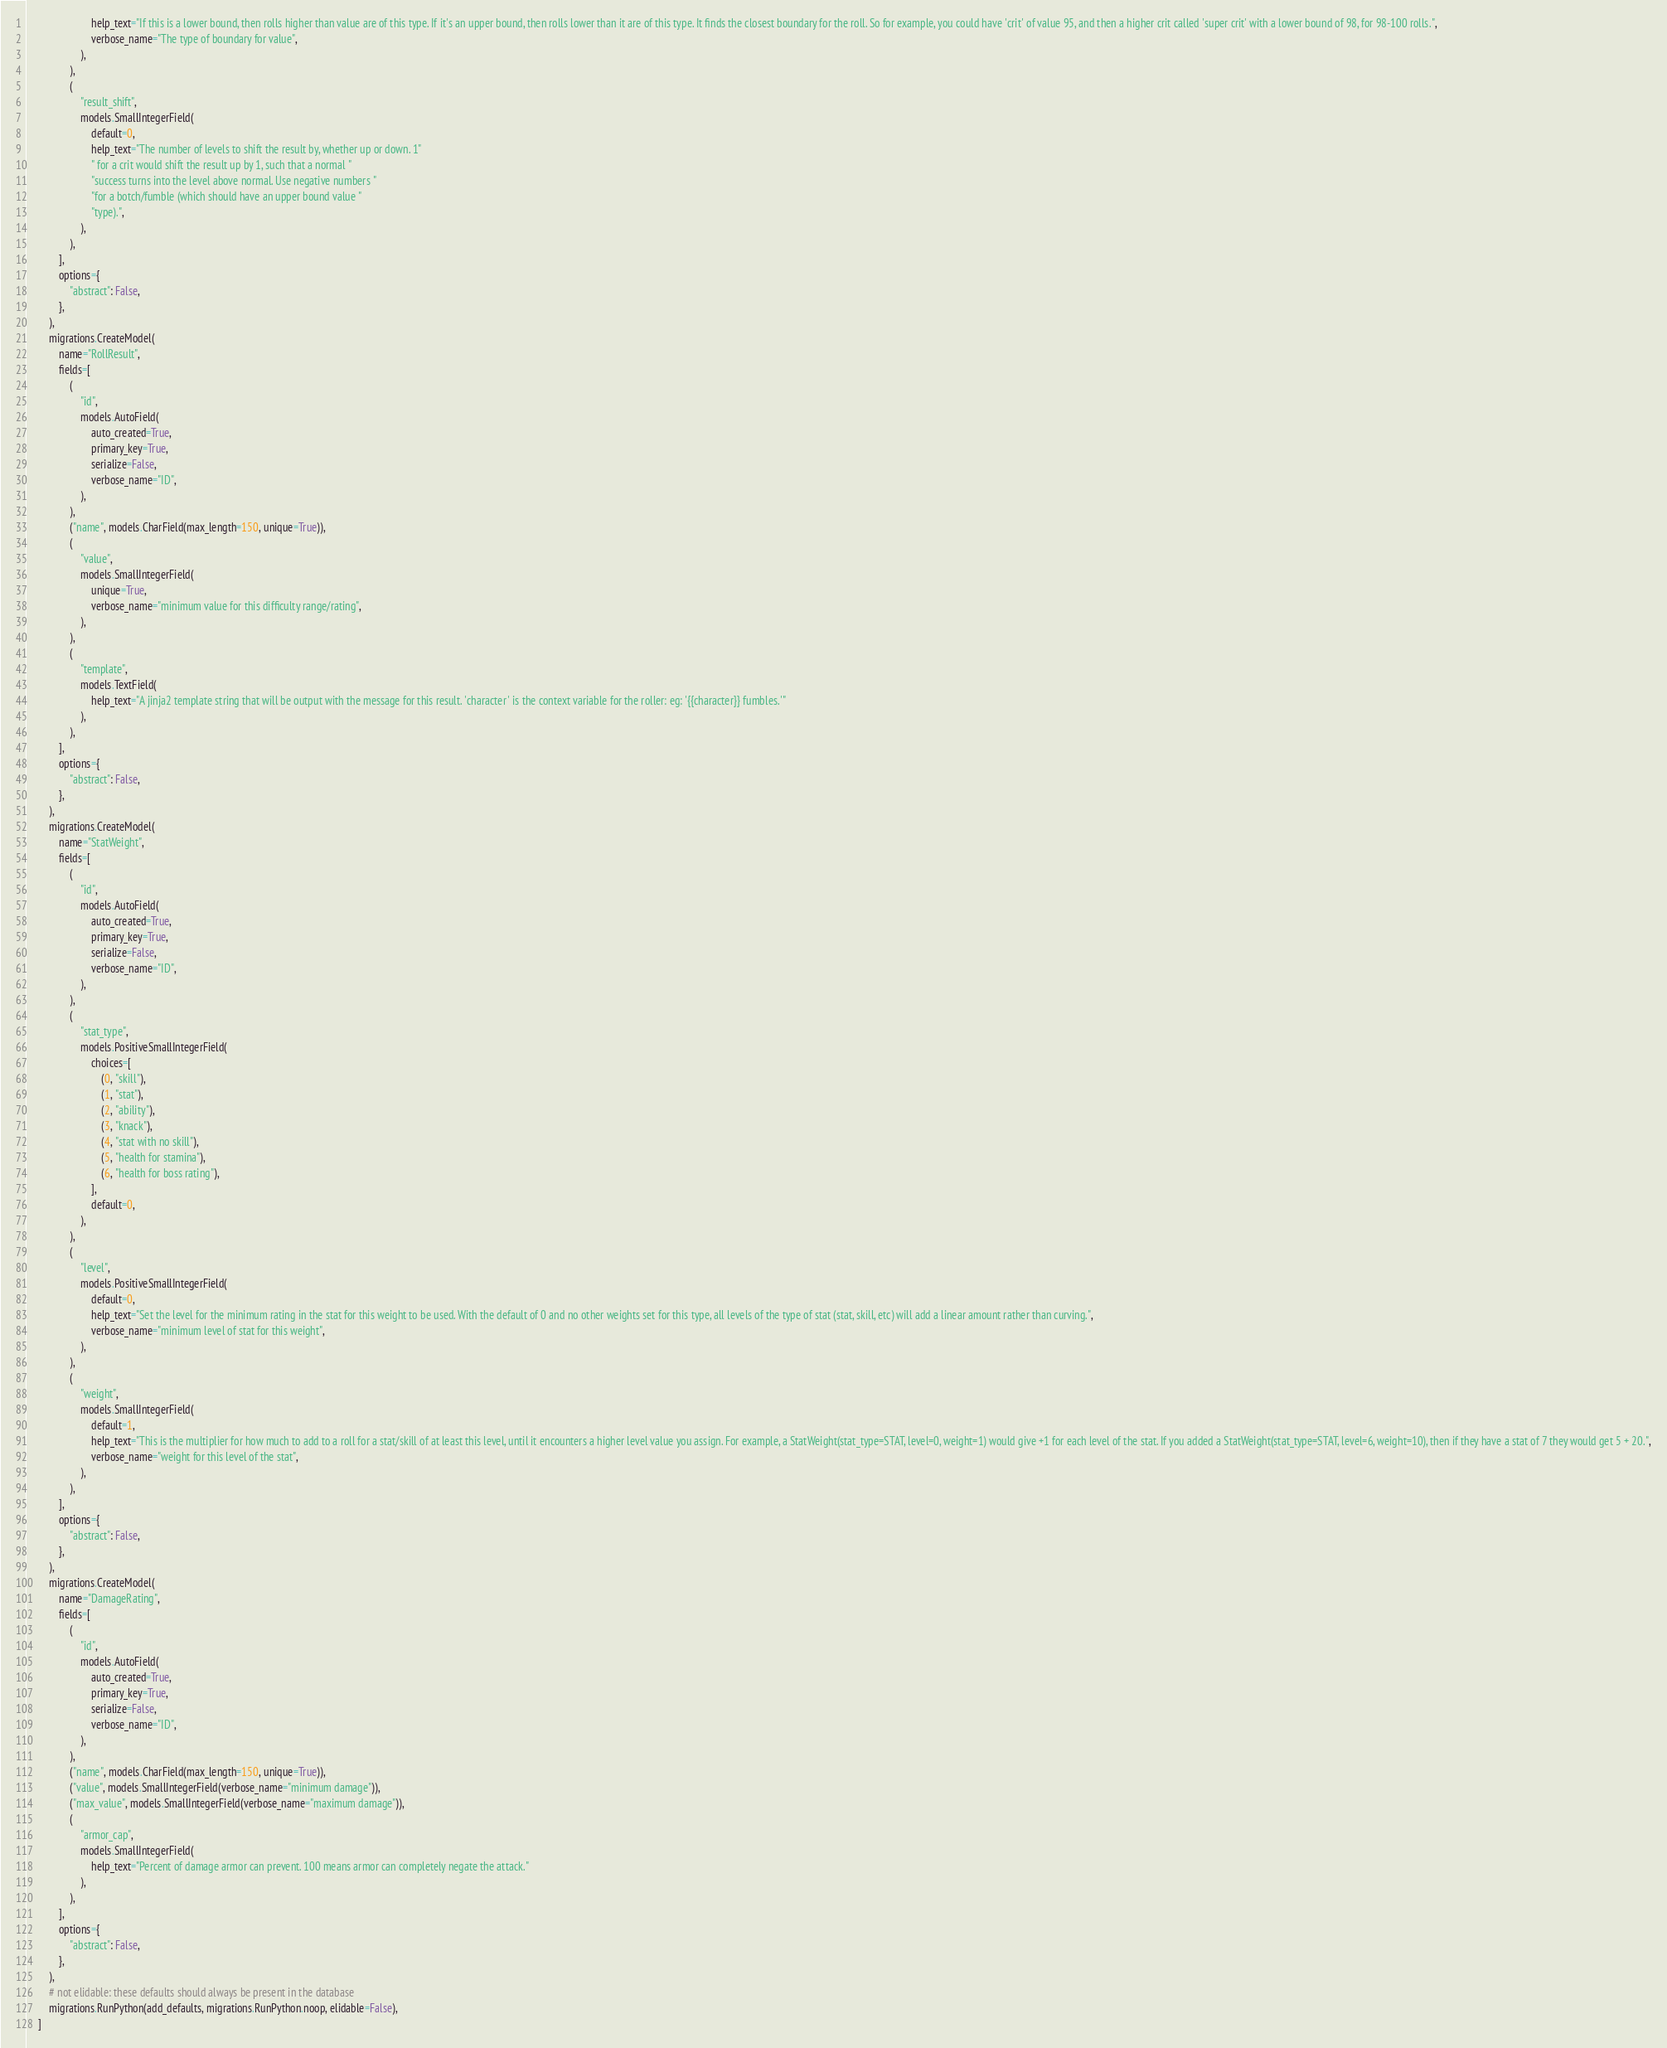Convert code to text. <code><loc_0><loc_0><loc_500><loc_500><_Python_>                        help_text="If this is a lower bound, then rolls higher than value are of this type. If it's an upper bound, then rolls lower than it are of this type. It finds the closest boundary for the roll. So for example, you could have 'crit' of value 95, and then a higher crit called 'super crit' with a lower bound of 98, for 98-100 rolls.",
                        verbose_name="The type of boundary for value",
                    ),
                ),
                (
                    "result_shift",
                    models.SmallIntegerField(
                        default=0,
                        help_text="The number of levels to shift the result by, whether up or down. 1"
                        " for a crit would shift the result up by 1, such that a normal "
                        "success turns into the level above normal. Use negative numbers "
                        "for a botch/fumble (which should have an upper bound value "
                        "type).",
                    ),
                ),
            ],
            options={
                "abstract": False,
            },
        ),
        migrations.CreateModel(
            name="RollResult",
            fields=[
                (
                    "id",
                    models.AutoField(
                        auto_created=True,
                        primary_key=True,
                        serialize=False,
                        verbose_name="ID",
                    ),
                ),
                ("name", models.CharField(max_length=150, unique=True)),
                (
                    "value",
                    models.SmallIntegerField(
                        unique=True,
                        verbose_name="minimum value for this difficulty range/rating",
                    ),
                ),
                (
                    "template",
                    models.TextField(
                        help_text="A jinja2 template string that will be output with the message for this result. 'character' is the context variable for the roller: eg: '{{character}} fumbles.'"
                    ),
                ),
            ],
            options={
                "abstract": False,
            },
        ),
        migrations.CreateModel(
            name="StatWeight",
            fields=[
                (
                    "id",
                    models.AutoField(
                        auto_created=True,
                        primary_key=True,
                        serialize=False,
                        verbose_name="ID",
                    ),
                ),
                (
                    "stat_type",
                    models.PositiveSmallIntegerField(
                        choices=[
                            (0, "skill"),
                            (1, "stat"),
                            (2, "ability"),
                            (3, "knack"),
                            (4, "stat with no skill"),
                            (5, "health for stamina"),
                            (6, "health for boss rating"),
                        ],
                        default=0,
                    ),
                ),
                (
                    "level",
                    models.PositiveSmallIntegerField(
                        default=0,
                        help_text="Set the level for the minimum rating in the stat for this weight to be used. With the default of 0 and no other weights set for this type, all levels of the type of stat (stat, skill, etc) will add a linear amount rather than curving.",
                        verbose_name="minimum level of stat for this weight",
                    ),
                ),
                (
                    "weight",
                    models.SmallIntegerField(
                        default=1,
                        help_text="This is the multiplier for how much to add to a roll for a stat/skill of at least this level, until it encounters a higher level value you assign. For example, a StatWeight(stat_type=STAT, level=0, weight=1) would give +1 for each level of the stat. If you added a StatWeight(stat_type=STAT, level=6, weight=10), then if they have a stat of 7 they would get 5 + 20.",
                        verbose_name="weight for this level of the stat",
                    ),
                ),
            ],
            options={
                "abstract": False,
            },
        ),
        migrations.CreateModel(
            name="DamageRating",
            fields=[
                (
                    "id",
                    models.AutoField(
                        auto_created=True,
                        primary_key=True,
                        serialize=False,
                        verbose_name="ID",
                    ),
                ),
                ("name", models.CharField(max_length=150, unique=True)),
                ("value", models.SmallIntegerField(verbose_name="minimum damage")),
                ("max_value", models.SmallIntegerField(verbose_name="maximum damage")),
                (
                    "armor_cap",
                    models.SmallIntegerField(
                        help_text="Percent of damage armor can prevent. 100 means armor can completely negate the attack."
                    ),
                ),
            ],
            options={
                "abstract": False,
            },
        ),
        # not elidable: these defaults should always be present in the database
        migrations.RunPython(add_defaults, migrations.RunPython.noop, elidable=False),
    ]
</code> 